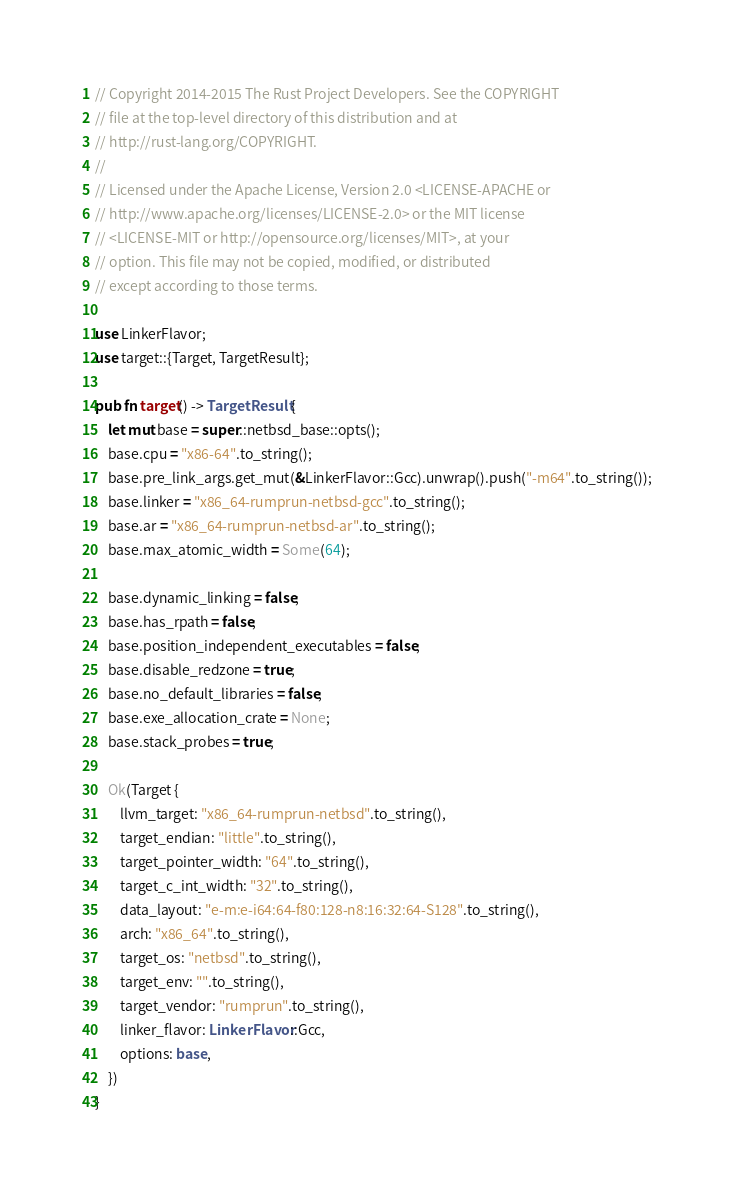Convert code to text. <code><loc_0><loc_0><loc_500><loc_500><_Rust_>// Copyright 2014-2015 The Rust Project Developers. See the COPYRIGHT
// file at the top-level directory of this distribution and at
// http://rust-lang.org/COPYRIGHT.
//
// Licensed under the Apache License, Version 2.0 <LICENSE-APACHE or
// http://www.apache.org/licenses/LICENSE-2.0> or the MIT license
// <LICENSE-MIT or http://opensource.org/licenses/MIT>, at your
// option. This file may not be copied, modified, or distributed
// except according to those terms.

use LinkerFlavor;
use target::{Target, TargetResult};

pub fn target() -> TargetResult {
    let mut base = super::netbsd_base::opts();
    base.cpu = "x86-64".to_string();
    base.pre_link_args.get_mut(&LinkerFlavor::Gcc).unwrap().push("-m64".to_string());
    base.linker = "x86_64-rumprun-netbsd-gcc".to_string();
    base.ar = "x86_64-rumprun-netbsd-ar".to_string();
    base.max_atomic_width = Some(64);

    base.dynamic_linking = false;
    base.has_rpath = false;
    base.position_independent_executables = false;
    base.disable_redzone = true;
    base.no_default_libraries = false;
    base.exe_allocation_crate = None;
    base.stack_probes = true;

    Ok(Target {
        llvm_target: "x86_64-rumprun-netbsd".to_string(),
        target_endian: "little".to_string(),
        target_pointer_width: "64".to_string(),
        target_c_int_width: "32".to_string(),
        data_layout: "e-m:e-i64:64-f80:128-n8:16:32:64-S128".to_string(),
        arch: "x86_64".to_string(),
        target_os: "netbsd".to_string(),
        target_env: "".to_string(),
        target_vendor: "rumprun".to_string(),
        linker_flavor: LinkerFlavor::Gcc,
        options: base,
    })
}
</code> 